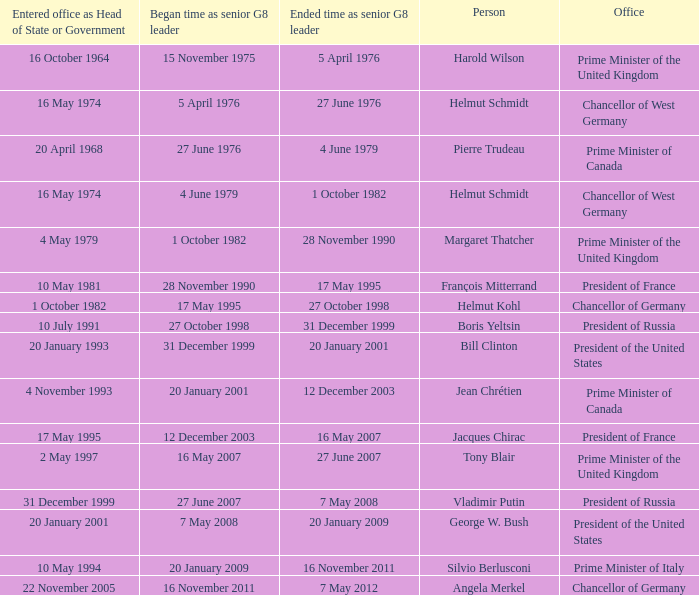When did jacques chirac cease being a g8 leader? 16 May 2007. 